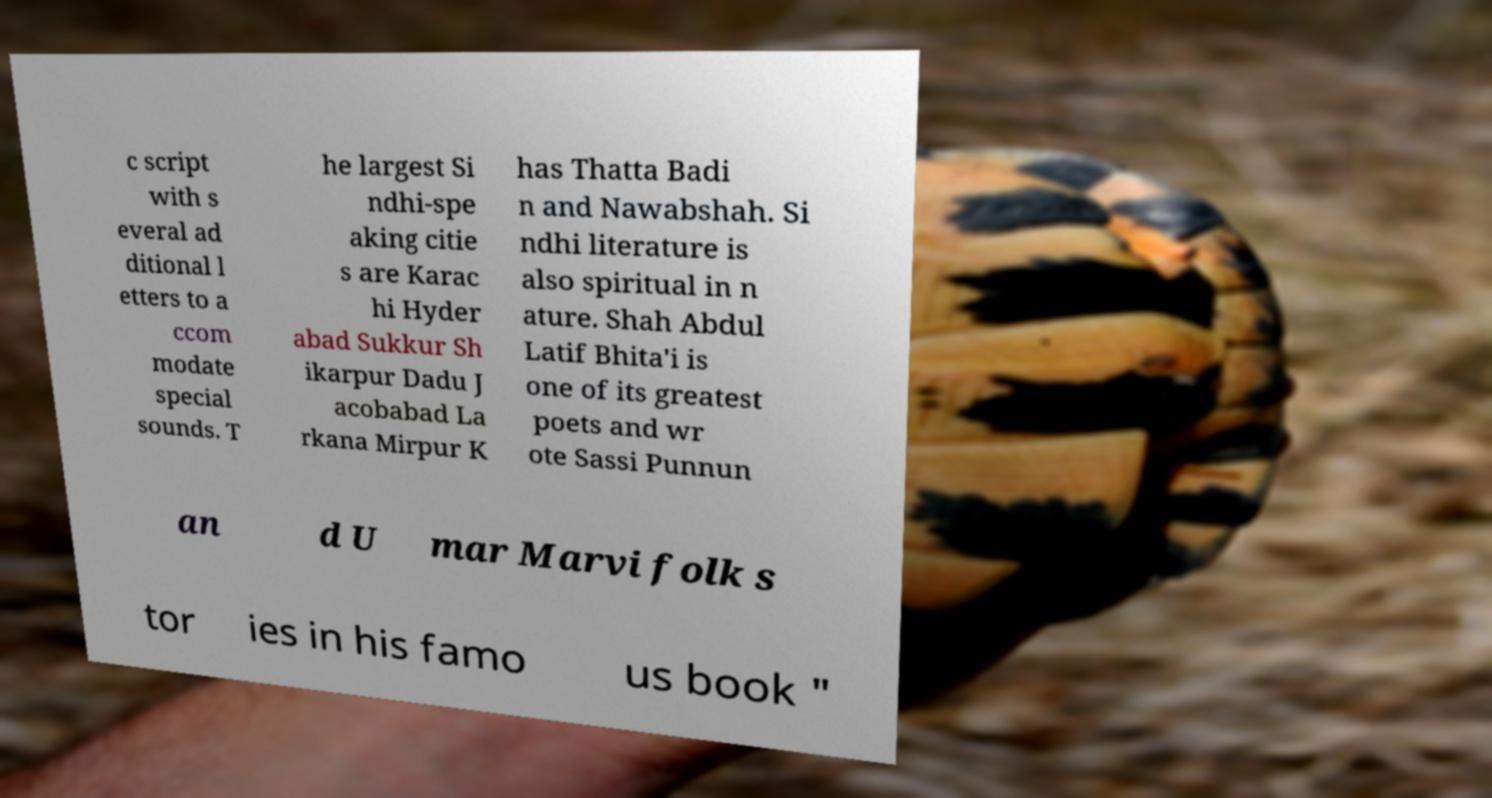I need the written content from this picture converted into text. Can you do that? c script with s everal ad ditional l etters to a ccom modate special sounds. T he largest Si ndhi-spe aking citie s are Karac hi Hyder abad Sukkur Sh ikarpur Dadu J acobabad La rkana Mirpur K has Thatta Badi n and Nawabshah. Si ndhi literature is also spiritual in n ature. Shah Abdul Latif Bhita'i is one of its greatest poets and wr ote Sassi Punnun an d U mar Marvi folk s tor ies in his famo us book " 